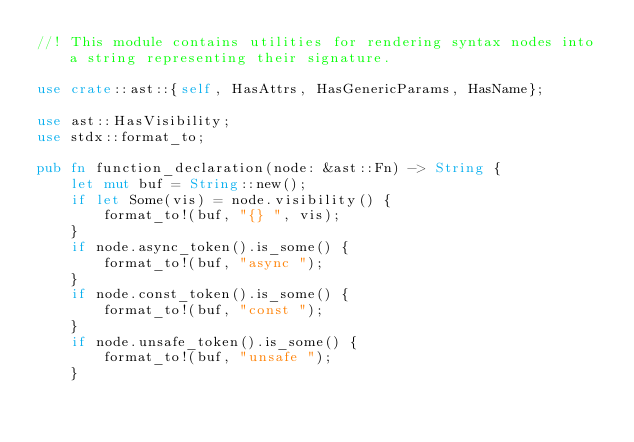<code> <loc_0><loc_0><loc_500><loc_500><_Rust_>//! This module contains utilities for rendering syntax nodes into a string representing their signature.

use crate::ast::{self, HasAttrs, HasGenericParams, HasName};

use ast::HasVisibility;
use stdx::format_to;

pub fn function_declaration(node: &ast::Fn) -> String {
    let mut buf = String::new();
    if let Some(vis) = node.visibility() {
        format_to!(buf, "{} ", vis);
    }
    if node.async_token().is_some() {
        format_to!(buf, "async ");
    }
    if node.const_token().is_some() {
        format_to!(buf, "const ");
    }
    if node.unsafe_token().is_some() {
        format_to!(buf, "unsafe ");
    }</code> 